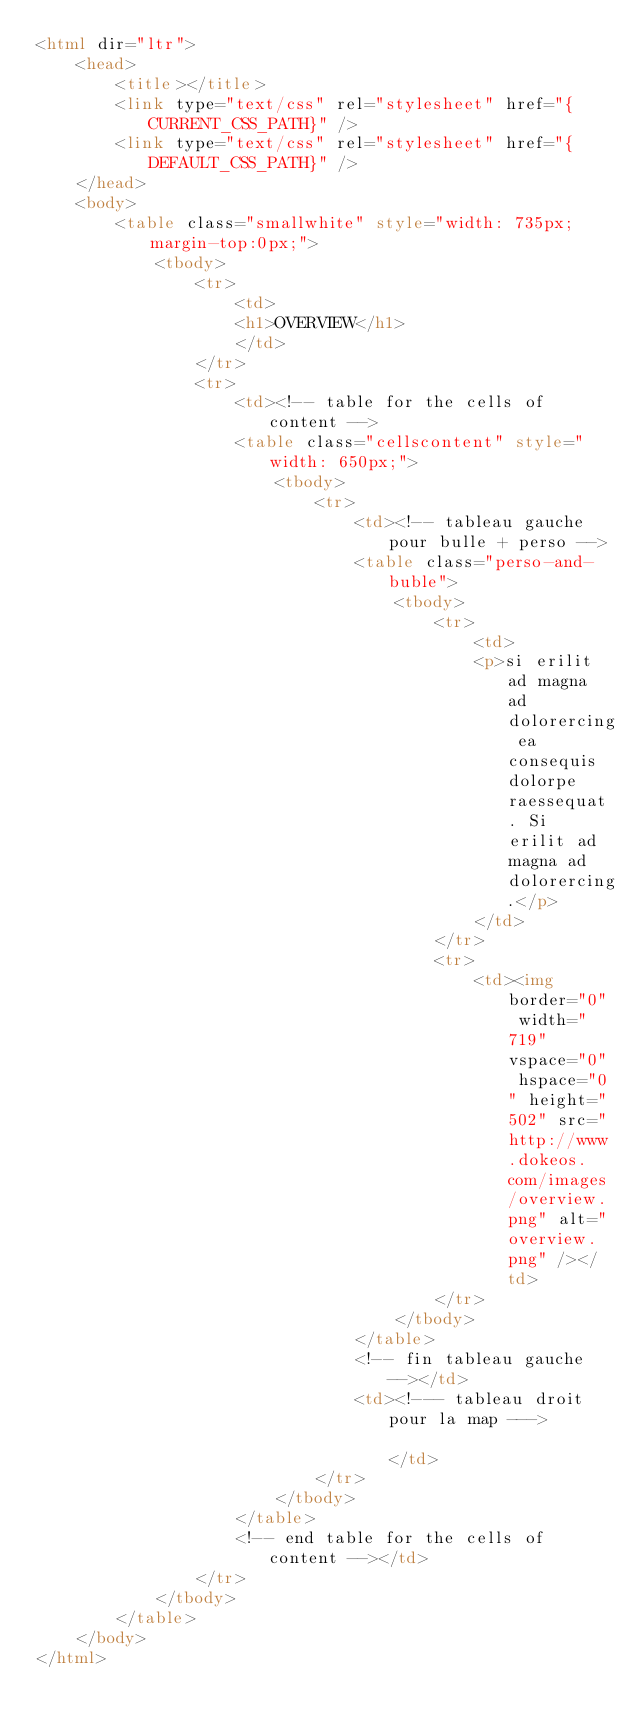Convert code to text. <code><loc_0><loc_0><loc_500><loc_500><_HTML_><html dir="ltr">
    <head>
        <title></title>
        <link type="text/css" rel="stylesheet" href="{CURRENT_CSS_PATH}" />
        <link type="text/css" rel="stylesheet" href="{DEFAULT_CSS_PATH}" />
    </head>
    <body>
        <table class="smallwhite" style="width: 735px;margin-top:0px;">
            <tbody>
                <tr>
                    <td>
                    <h1>OVERVIEW</h1>
                    </td>
                </tr>
                <tr>
                    <td><!-- table for the cells of content -->
                    <table class="cellscontent" style="width: 650px;">
                        <tbody>
                            <tr>
                                <td><!-- tableau gauche pour bulle + perso -->
                                <table class="perso-and-buble">
                                    <tbody>
                                        <tr>
                                            <td>
                                            <p>si erilit ad magna ad dolorercing ea consequis dolorpe raessequat. Si erilit ad magna ad dolorercing.</p>
                                            </td>
                                        </tr>
                                        <tr>
                                            <td><img border="0" width="719" vspace="0" hspace="0" height="502" src="http://www.dokeos.com/images/overview.png" alt="overview.png" /></td>
                                        </tr>
                                    </tbody>
                                </table>
                                <!-- fin tableau gauche --></td>
                                <td><!--- tableau droit pour la map --->                                  	</td>
                            </tr>
                        </tbody>
                    </table>
                    <!-- end table for the cells of content --></td>
                </tr>
            </tbody>
        </table>
    </body>
</html>
</code> 